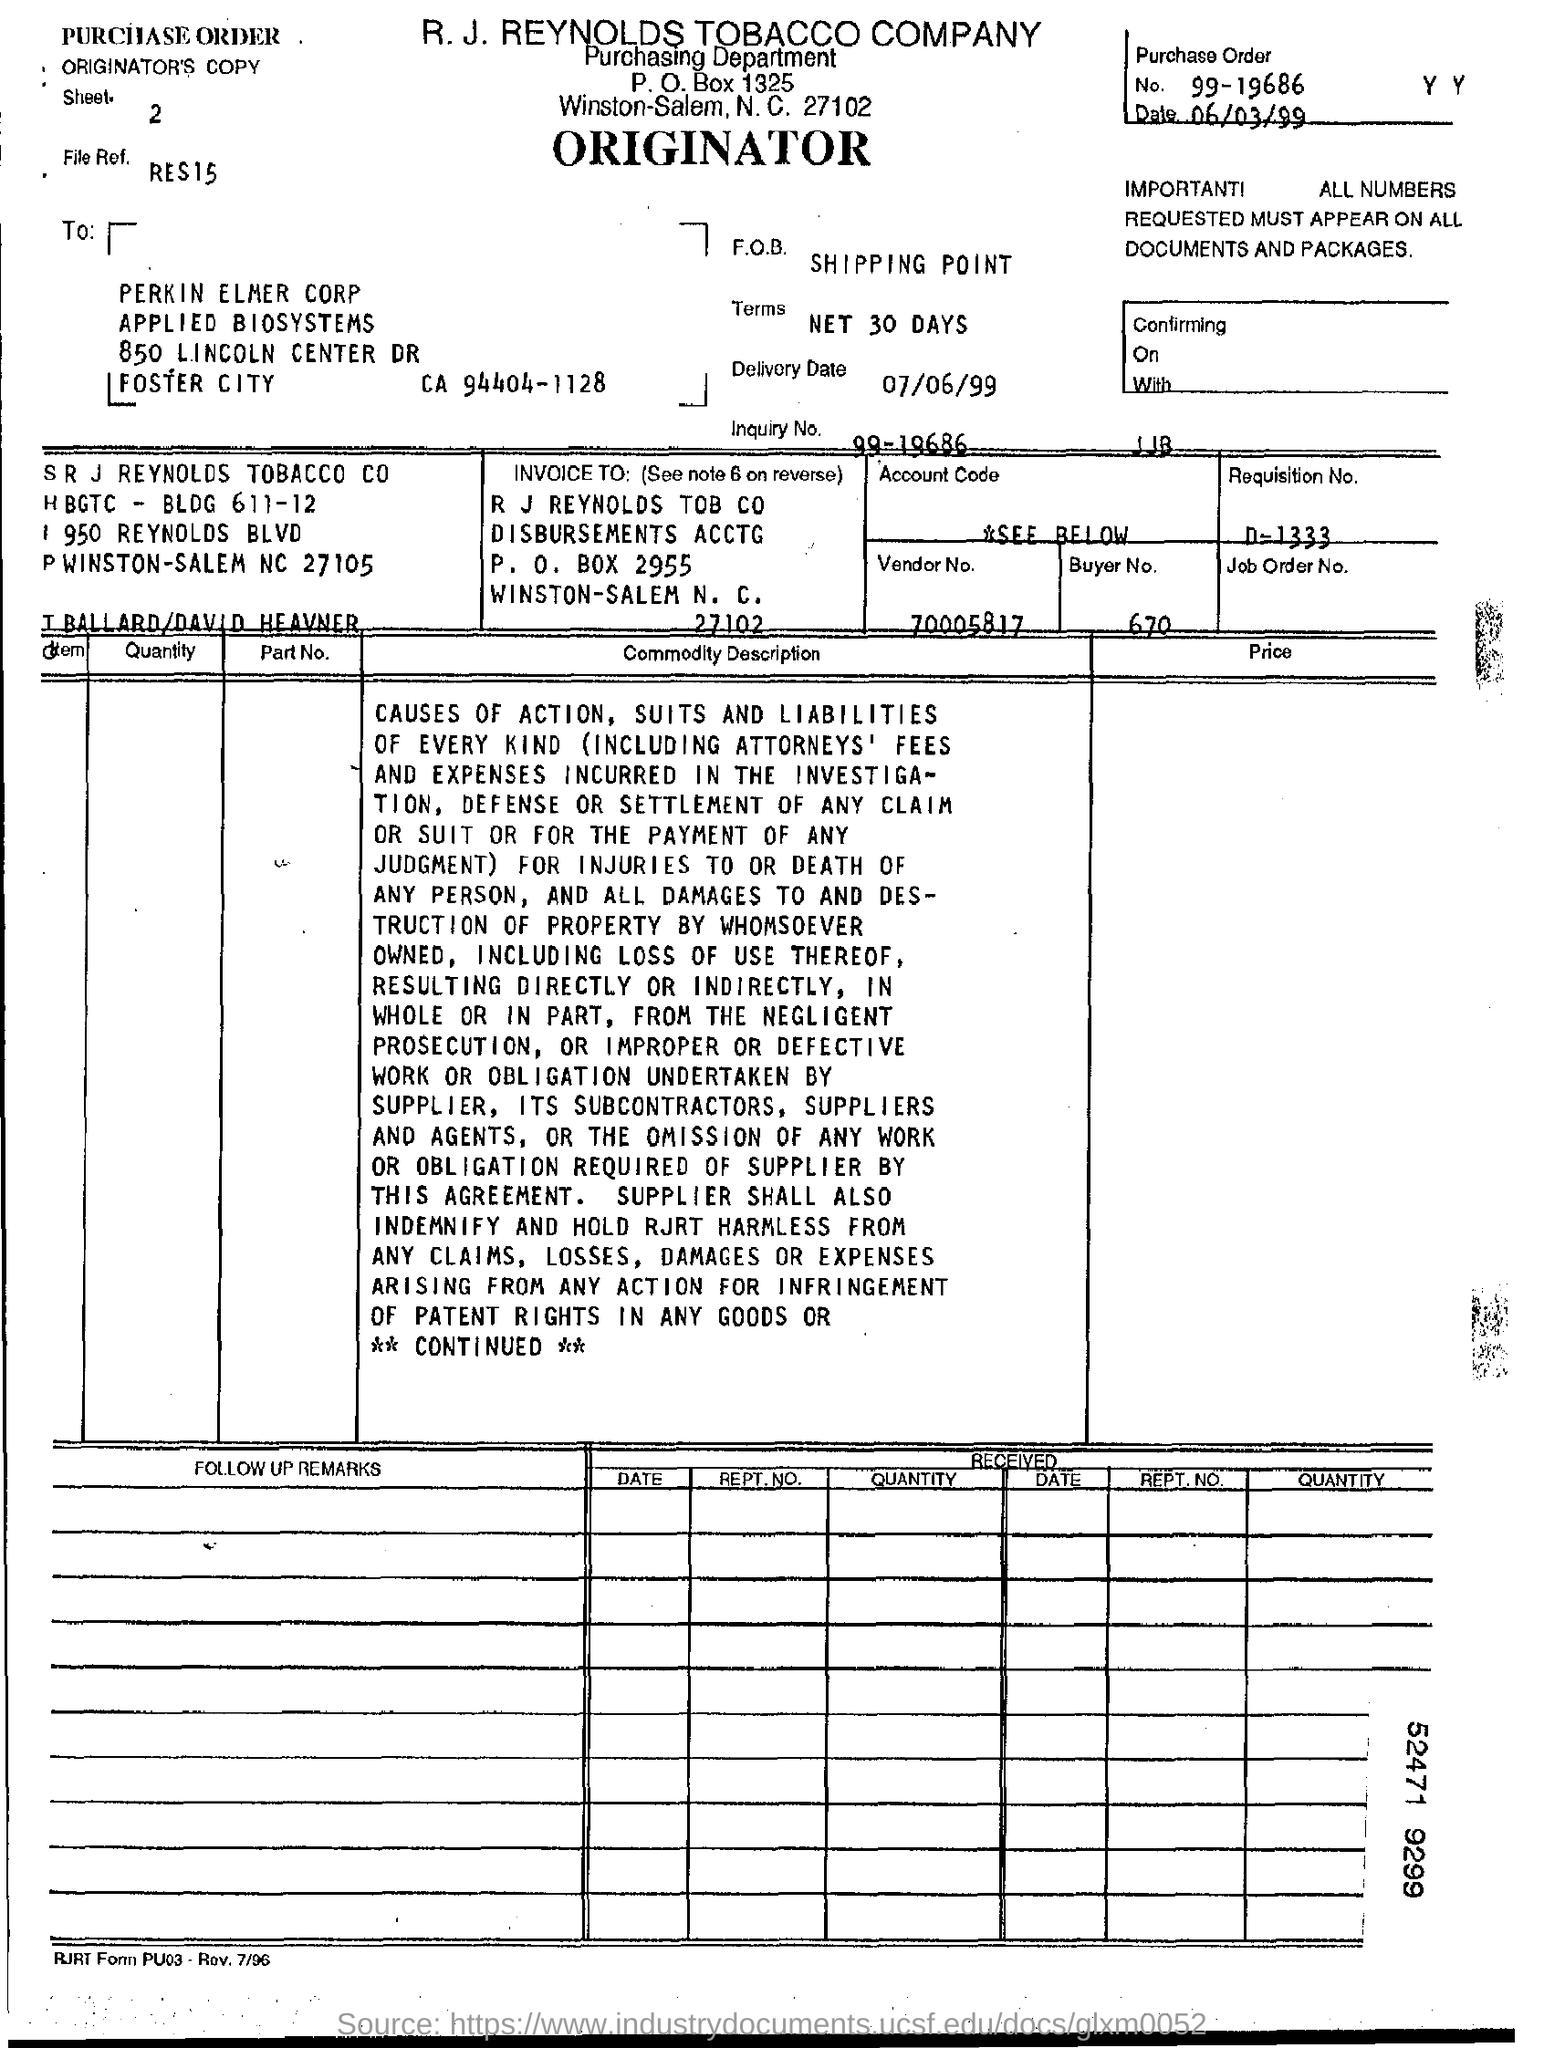What is the purchase order no.?
Ensure brevity in your answer.  99-19686. What is the zipcode of r j reynolds tobacco company ?
Provide a short and direct response. 27102. Mention the delivery date ?
Provide a succinct answer. 07/06/99. What is the vendor no. ?
Your response must be concise. 70005817. What is the p.o box number of r j reynolds tob co ?
Provide a short and direct response. 2955. 